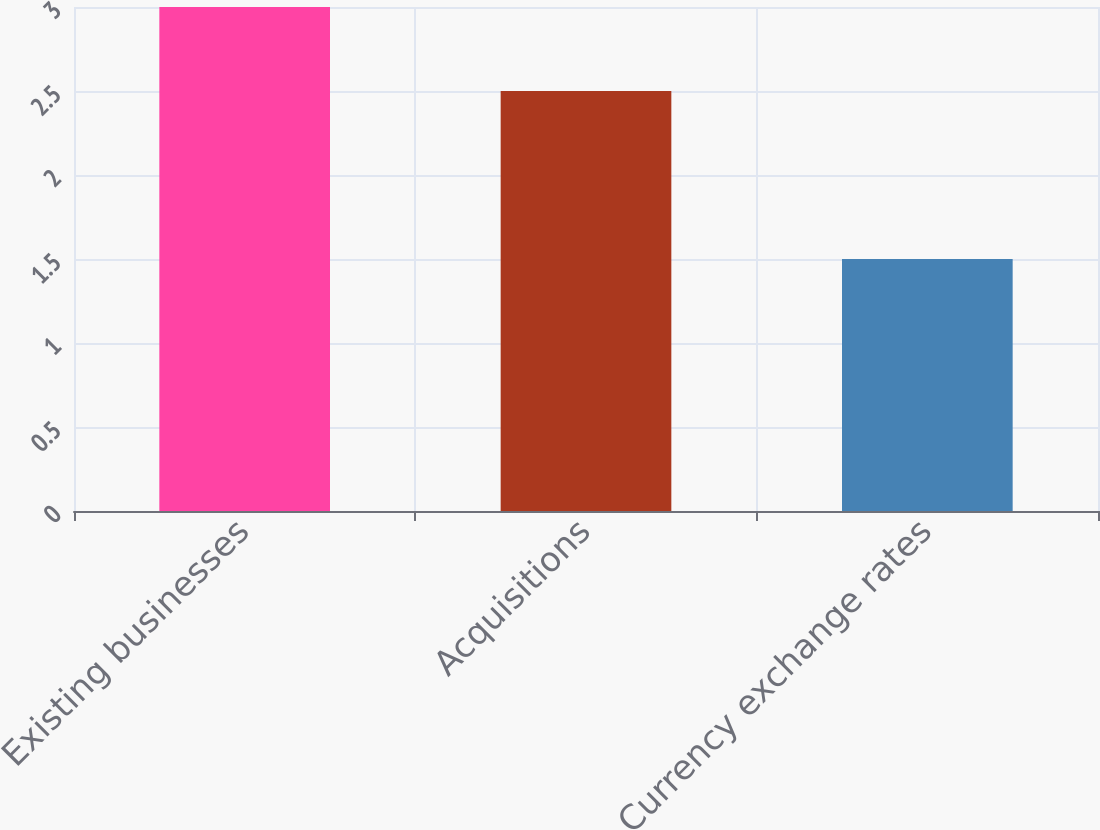Convert chart. <chart><loc_0><loc_0><loc_500><loc_500><bar_chart><fcel>Existing businesses<fcel>Acquisitions<fcel>Currency exchange rates<nl><fcel>3<fcel>2.5<fcel>1.5<nl></chart> 